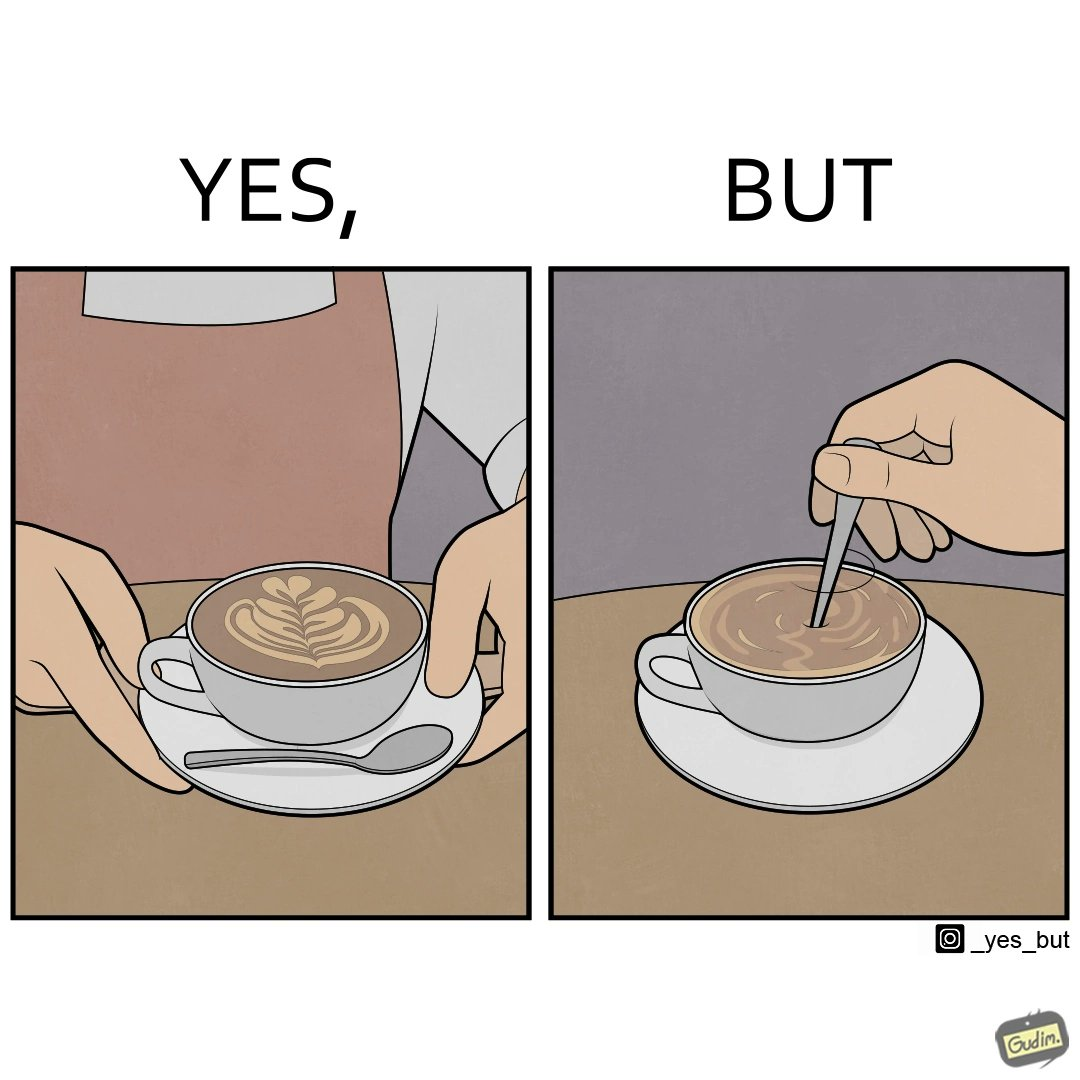Is there satirical content in this image? Yes, this image is satirical. 